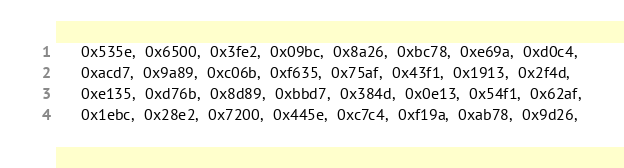Convert code to text. <code><loc_0><loc_0><loc_500><loc_500><_Ruby_>      0x535e,  0x6500,  0x3fe2,  0x09bc,  0x8a26,  0xbc78,  0xe69a,  0xd0c4,
      0xacd7,  0x9a89,  0xc06b,  0xf635,  0x75af,  0x43f1,  0x1913,  0x2f4d,
      0xe135,  0xd76b,  0x8d89,  0xbbd7,  0x384d,  0x0e13,  0x54f1,  0x62af,
      0x1ebc,  0x28e2,  0x7200,  0x445e,  0xc7c4,  0xf19a,  0xab78,  0x9d26,</code> 